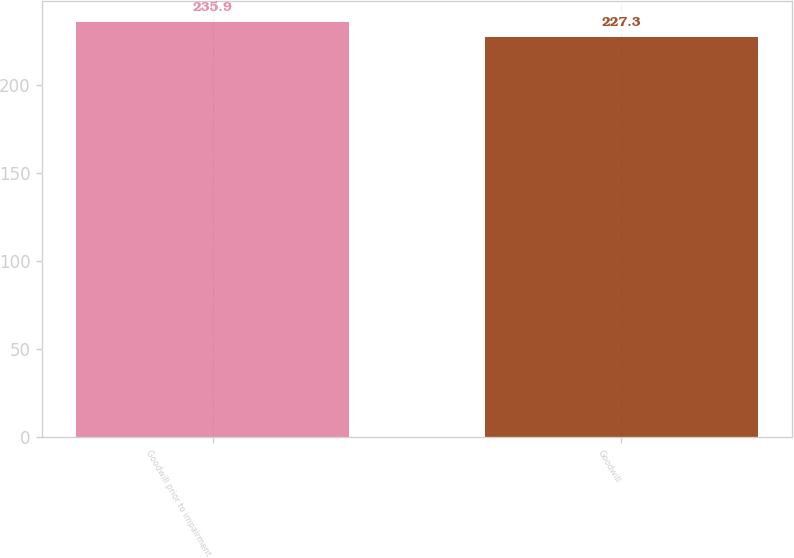Convert chart to OTSL. <chart><loc_0><loc_0><loc_500><loc_500><bar_chart><fcel>Goodwill prior to impairment<fcel>Goodwill<nl><fcel>235.9<fcel>227.3<nl></chart> 